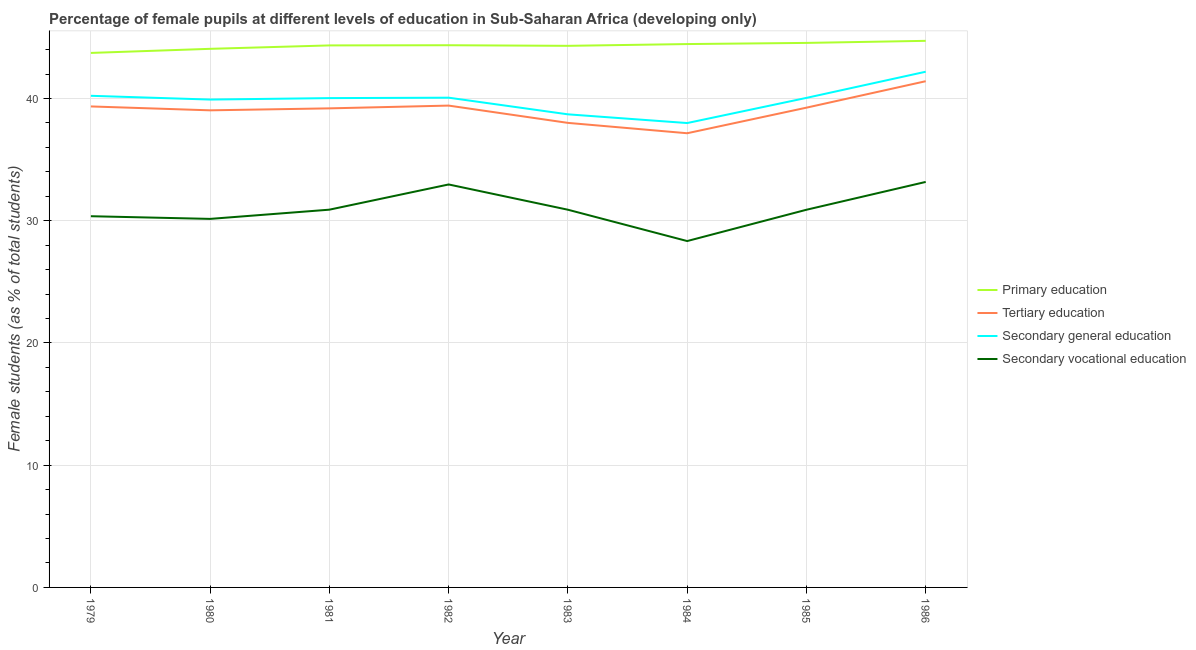How many different coloured lines are there?
Your answer should be compact. 4. Is the number of lines equal to the number of legend labels?
Your response must be concise. Yes. What is the percentage of female students in tertiary education in 1982?
Provide a short and direct response. 39.42. Across all years, what is the maximum percentage of female students in secondary vocational education?
Your answer should be compact. 33.17. Across all years, what is the minimum percentage of female students in secondary vocational education?
Give a very brief answer. 28.34. In which year was the percentage of female students in primary education maximum?
Offer a terse response. 1986. In which year was the percentage of female students in secondary education minimum?
Your answer should be compact. 1984. What is the total percentage of female students in secondary vocational education in the graph?
Ensure brevity in your answer.  247.69. What is the difference between the percentage of female students in secondary vocational education in 1985 and that in 1986?
Your answer should be very brief. -2.28. What is the difference between the percentage of female students in tertiary education in 1982 and the percentage of female students in primary education in 1983?
Offer a terse response. -4.89. What is the average percentage of female students in secondary education per year?
Provide a short and direct response. 39.89. In the year 1982, what is the difference between the percentage of female students in tertiary education and percentage of female students in secondary vocational education?
Your answer should be very brief. 6.45. In how many years, is the percentage of female students in primary education greater than 16 %?
Keep it short and to the point. 8. What is the ratio of the percentage of female students in secondary vocational education in 1981 to that in 1983?
Offer a very short reply. 1. What is the difference between the highest and the second highest percentage of female students in tertiary education?
Offer a very short reply. 1.99. What is the difference between the highest and the lowest percentage of female students in tertiary education?
Your answer should be very brief. 4.26. In how many years, is the percentage of female students in secondary vocational education greater than the average percentage of female students in secondary vocational education taken over all years?
Give a very brief answer. 2. What is the difference between two consecutive major ticks on the Y-axis?
Offer a very short reply. 10. Are the values on the major ticks of Y-axis written in scientific E-notation?
Keep it short and to the point. No. Does the graph contain any zero values?
Provide a succinct answer. No. Where does the legend appear in the graph?
Provide a succinct answer. Center right. What is the title of the graph?
Your answer should be compact. Percentage of female pupils at different levels of education in Sub-Saharan Africa (developing only). What is the label or title of the Y-axis?
Provide a succinct answer. Female students (as % of total students). What is the Female students (as % of total students) of Primary education in 1979?
Ensure brevity in your answer.  43.73. What is the Female students (as % of total students) in Tertiary education in 1979?
Make the answer very short. 39.35. What is the Female students (as % of total students) of Secondary general education in 1979?
Your answer should be very brief. 40.22. What is the Female students (as % of total students) in Secondary vocational education in 1979?
Your response must be concise. 30.37. What is the Female students (as % of total students) in Primary education in 1980?
Give a very brief answer. 44.06. What is the Female students (as % of total students) of Tertiary education in 1980?
Provide a short and direct response. 39.03. What is the Female students (as % of total students) of Secondary general education in 1980?
Your answer should be compact. 39.91. What is the Female students (as % of total students) of Secondary vocational education in 1980?
Offer a terse response. 30.15. What is the Female students (as % of total students) of Primary education in 1981?
Your answer should be very brief. 44.34. What is the Female students (as % of total students) in Tertiary education in 1981?
Provide a short and direct response. 39.19. What is the Female students (as % of total students) of Secondary general education in 1981?
Provide a succinct answer. 40.03. What is the Female students (as % of total students) of Secondary vocational education in 1981?
Your answer should be compact. 30.9. What is the Female students (as % of total students) of Primary education in 1982?
Offer a very short reply. 44.36. What is the Female students (as % of total students) of Tertiary education in 1982?
Ensure brevity in your answer.  39.42. What is the Female students (as % of total students) in Secondary general education in 1982?
Give a very brief answer. 40.06. What is the Female students (as % of total students) in Secondary vocational education in 1982?
Offer a very short reply. 32.97. What is the Female students (as % of total students) of Primary education in 1983?
Your response must be concise. 44.31. What is the Female students (as % of total students) of Tertiary education in 1983?
Offer a terse response. 38. What is the Female students (as % of total students) of Secondary general education in 1983?
Ensure brevity in your answer.  38.7. What is the Female students (as % of total students) of Secondary vocational education in 1983?
Your response must be concise. 30.9. What is the Female students (as % of total students) of Primary education in 1984?
Provide a short and direct response. 44.45. What is the Female students (as % of total students) in Tertiary education in 1984?
Your answer should be very brief. 37.16. What is the Female students (as % of total students) in Secondary general education in 1984?
Offer a terse response. 37.99. What is the Female students (as % of total students) of Secondary vocational education in 1984?
Your answer should be very brief. 28.34. What is the Female students (as % of total students) in Primary education in 1985?
Provide a succinct answer. 44.54. What is the Female students (as % of total students) in Tertiary education in 1985?
Give a very brief answer. 39.25. What is the Female students (as % of total students) of Secondary general education in 1985?
Offer a very short reply. 40.05. What is the Female students (as % of total students) in Secondary vocational education in 1985?
Provide a short and direct response. 30.9. What is the Female students (as % of total students) in Primary education in 1986?
Offer a terse response. 44.71. What is the Female students (as % of total students) of Tertiary education in 1986?
Provide a short and direct response. 41.41. What is the Female students (as % of total students) in Secondary general education in 1986?
Ensure brevity in your answer.  42.19. What is the Female students (as % of total students) of Secondary vocational education in 1986?
Provide a succinct answer. 33.17. Across all years, what is the maximum Female students (as % of total students) of Primary education?
Your answer should be very brief. 44.71. Across all years, what is the maximum Female students (as % of total students) in Tertiary education?
Ensure brevity in your answer.  41.41. Across all years, what is the maximum Female students (as % of total students) in Secondary general education?
Provide a short and direct response. 42.19. Across all years, what is the maximum Female students (as % of total students) of Secondary vocational education?
Offer a very short reply. 33.17. Across all years, what is the minimum Female students (as % of total students) of Primary education?
Keep it short and to the point. 43.73. Across all years, what is the minimum Female students (as % of total students) in Tertiary education?
Your answer should be compact. 37.16. Across all years, what is the minimum Female students (as % of total students) in Secondary general education?
Keep it short and to the point. 37.99. Across all years, what is the minimum Female students (as % of total students) in Secondary vocational education?
Make the answer very short. 28.34. What is the total Female students (as % of total students) of Primary education in the graph?
Make the answer very short. 354.5. What is the total Female students (as % of total students) of Tertiary education in the graph?
Ensure brevity in your answer.  312.8. What is the total Female students (as % of total students) in Secondary general education in the graph?
Make the answer very short. 319.15. What is the total Female students (as % of total students) of Secondary vocational education in the graph?
Make the answer very short. 247.69. What is the difference between the Female students (as % of total students) in Primary education in 1979 and that in 1980?
Your answer should be compact. -0.34. What is the difference between the Female students (as % of total students) of Tertiary education in 1979 and that in 1980?
Ensure brevity in your answer.  0.32. What is the difference between the Female students (as % of total students) of Secondary general education in 1979 and that in 1980?
Your response must be concise. 0.31. What is the difference between the Female students (as % of total students) in Secondary vocational education in 1979 and that in 1980?
Your response must be concise. 0.22. What is the difference between the Female students (as % of total students) of Primary education in 1979 and that in 1981?
Your answer should be very brief. -0.61. What is the difference between the Female students (as % of total students) of Tertiary education in 1979 and that in 1981?
Offer a terse response. 0.16. What is the difference between the Female students (as % of total students) of Secondary general education in 1979 and that in 1981?
Offer a terse response. 0.19. What is the difference between the Female students (as % of total students) in Secondary vocational education in 1979 and that in 1981?
Provide a short and direct response. -0.54. What is the difference between the Female students (as % of total students) of Primary education in 1979 and that in 1982?
Your answer should be compact. -0.63. What is the difference between the Female students (as % of total students) in Tertiary education in 1979 and that in 1982?
Your answer should be very brief. -0.07. What is the difference between the Female students (as % of total students) of Secondary general education in 1979 and that in 1982?
Provide a succinct answer. 0.15. What is the difference between the Female students (as % of total students) in Secondary vocational education in 1979 and that in 1982?
Make the answer very short. -2.6. What is the difference between the Female students (as % of total students) of Primary education in 1979 and that in 1983?
Provide a succinct answer. -0.58. What is the difference between the Female students (as % of total students) in Tertiary education in 1979 and that in 1983?
Make the answer very short. 1.34. What is the difference between the Female students (as % of total students) in Secondary general education in 1979 and that in 1983?
Your answer should be very brief. 1.52. What is the difference between the Female students (as % of total students) of Secondary vocational education in 1979 and that in 1983?
Your answer should be very brief. -0.53. What is the difference between the Female students (as % of total students) in Primary education in 1979 and that in 1984?
Offer a very short reply. -0.73. What is the difference between the Female students (as % of total students) of Tertiary education in 1979 and that in 1984?
Your answer should be compact. 2.19. What is the difference between the Female students (as % of total students) in Secondary general education in 1979 and that in 1984?
Keep it short and to the point. 2.23. What is the difference between the Female students (as % of total students) of Secondary vocational education in 1979 and that in 1984?
Provide a succinct answer. 2.03. What is the difference between the Female students (as % of total students) of Primary education in 1979 and that in 1985?
Your response must be concise. -0.82. What is the difference between the Female students (as % of total students) of Tertiary education in 1979 and that in 1985?
Offer a terse response. 0.1. What is the difference between the Female students (as % of total students) of Secondary general education in 1979 and that in 1985?
Your answer should be very brief. 0.17. What is the difference between the Female students (as % of total students) of Secondary vocational education in 1979 and that in 1985?
Provide a succinct answer. -0.53. What is the difference between the Female students (as % of total students) of Primary education in 1979 and that in 1986?
Your response must be concise. -0.99. What is the difference between the Female students (as % of total students) in Tertiary education in 1979 and that in 1986?
Offer a very short reply. -2.06. What is the difference between the Female students (as % of total students) of Secondary general education in 1979 and that in 1986?
Offer a very short reply. -1.97. What is the difference between the Female students (as % of total students) of Secondary vocational education in 1979 and that in 1986?
Give a very brief answer. -2.8. What is the difference between the Female students (as % of total students) of Primary education in 1980 and that in 1981?
Your answer should be very brief. -0.28. What is the difference between the Female students (as % of total students) of Tertiary education in 1980 and that in 1981?
Your response must be concise. -0.16. What is the difference between the Female students (as % of total students) in Secondary general education in 1980 and that in 1981?
Make the answer very short. -0.12. What is the difference between the Female students (as % of total students) of Secondary vocational education in 1980 and that in 1981?
Your response must be concise. -0.75. What is the difference between the Female students (as % of total students) in Primary education in 1980 and that in 1982?
Provide a succinct answer. -0.29. What is the difference between the Female students (as % of total students) in Tertiary education in 1980 and that in 1982?
Keep it short and to the point. -0.39. What is the difference between the Female students (as % of total students) of Secondary general education in 1980 and that in 1982?
Your answer should be very brief. -0.15. What is the difference between the Female students (as % of total students) of Secondary vocational education in 1980 and that in 1982?
Keep it short and to the point. -2.82. What is the difference between the Female students (as % of total students) in Primary education in 1980 and that in 1983?
Provide a succinct answer. -0.24. What is the difference between the Female students (as % of total students) of Tertiary education in 1980 and that in 1983?
Your answer should be compact. 1.03. What is the difference between the Female students (as % of total students) in Secondary general education in 1980 and that in 1983?
Provide a succinct answer. 1.21. What is the difference between the Female students (as % of total students) in Secondary vocational education in 1980 and that in 1983?
Your response must be concise. -0.75. What is the difference between the Female students (as % of total students) in Primary education in 1980 and that in 1984?
Provide a succinct answer. -0.39. What is the difference between the Female students (as % of total students) in Tertiary education in 1980 and that in 1984?
Provide a succinct answer. 1.87. What is the difference between the Female students (as % of total students) of Secondary general education in 1980 and that in 1984?
Keep it short and to the point. 1.92. What is the difference between the Female students (as % of total students) of Secondary vocational education in 1980 and that in 1984?
Provide a succinct answer. 1.81. What is the difference between the Female students (as % of total students) in Primary education in 1980 and that in 1985?
Offer a very short reply. -0.48. What is the difference between the Female students (as % of total students) of Tertiary education in 1980 and that in 1985?
Provide a short and direct response. -0.22. What is the difference between the Female students (as % of total students) in Secondary general education in 1980 and that in 1985?
Ensure brevity in your answer.  -0.14. What is the difference between the Female students (as % of total students) in Secondary vocational education in 1980 and that in 1985?
Keep it short and to the point. -0.75. What is the difference between the Female students (as % of total students) of Primary education in 1980 and that in 1986?
Ensure brevity in your answer.  -0.65. What is the difference between the Female students (as % of total students) in Tertiary education in 1980 and that in 1986?
Make the answer very short. -2.38. What is the difference between the Female students (as % of total students) of Secondary general education in 1980 and that in 1986?
Provide a short and direct response. -2.28. What is the difference between the Female students (as % of total students) in Secondary vocational education in 1980 and that in 1986?
Your answer should be very brief. -3.02. What is the difference between the Female students (as % of total students) in Primary education in 1981 and that in 1982?
Provide a succinct answer. -0.01. What is the difference between the Female students (as % of total students) in Tertiary education in 1981 and that in 1982?
Provide a succinct answer. -0.23. What is the difference between the Female students (as % of total students) in Secondary general education in 1981 and that in 1982?
Provide a succinct answer. -0.04. What is the difference between the Female students (as % of total students) in Secondary vocational education in 1981 and that in 1982?
Give a very brief answer. -2.06. What is the difference between the Female students (as % of total students) of Primary education in 1981 and that in 1983?
Offer a very short reply. 0.03. What is the difference between the Female students (as % of total students) of Tertiary education in 1981 and that in 1983?
Make the answer very short. 1.19. What is the difference between the Female students (as % of total students) in Secondary general education in 1981 and that in 1983?
Provide a short and direct response. 1.33. What is the difference between the Female students (as % of total students) in Secondary vocational education in 1981 and that in 1983?
Provide a succinct answer. 0. What is the difference between the Female students (as % of total students) in Primary education in 1981 and that in 1984?
Provide a short and direct response. -0.11. What is the difference between the Female students (as % of total students) in Tertiary education in 1981 and that in 1984?
Provide a short and direct response. 2.04. What is the difference between the Female students (as % of total students) of Secondary general education in 1981 and that in 1984?
Make the answer very short. 2.04. What is the difference between the Female students (as % of total students) in Secondary vocational education in 1981 and that in 1984?
Ensure brevity in your answer.  2.57. What is the difference between the Female students (as % of total students) in Primary education in 1981 and that in 1985?
Offer a terse response. -0.2. What is the difference between the Female students (as % of total students) of Tertiary education in 1981 and that in 1985?
Your answer should be very brief. -0.06. What is the difference between the Female students (as % of total students) in Secondary general education in 1981 and that in 1985?
Offer a terse response. -0.02. What is the difference between the Female students (as % of total students) of Secondary vocational education in 1981 and that in 1985?
Your response must be concise. 0.01. What is the difference between the Female students (as % of total students) of Primary education in 1981 and that in 1986?
Offer a terse response. -0.37. What is the difference between the Female students (as % of total students) of Tertiary education in 1981 and that in 1986?
Give a very brief answer. -2.22. What is the difference between the Female students (as % of total students) in Secondary general education in 1981 and that in 1986?
Give a very brief answer. -2.16. What is the difference between the Female students (as % of total students) in Secondary vocational education in 1981 and that in 1986?
Ensure brevity in your answer.  -2.27. What is the difference between the Female students (as % of total students) in Primary education in 1982 and that in 1983?
Ensure brevity in your answer.  0.05. What is the difference between the Female students (as % of total students) in Tertiary education in 1982 and that in 1983?
Keep it short and to the point. 1.41. What is the difference between the Female students (as % of total students) of Secondary general education in 1982 and that in 1983?
Your answer should be very brief. 1.36. What is the difference between the Female students (as % of total students) of Secondary vocational education in 1982 and that in 1983?
Your response must be concise. 2.07. What is the difference between the Female students (as % of total students) of Primary education in 1982 and that in 1984?
Your answer should be compact. -0.1. What is the difference between the Female students (as % of total students) of Tertiary education in 1982 and that in 1984?
Provide a succinct answer. 2.26. What is the difference between the Female students (as % of total students) in Secondary general education in 1982 and that in 1984?
Keep it short and to the point. 2.07. What is the difference between the Female students (as % of total students) in Secondary vocational education in 1982 and that in 1984?
Your answer should be very brief. 4.63. What is the difference between the Female students (as % of total students) in Primary education in 1982 and that in 1985?
Offer a very short reply. -0.19. What is the difference between the Female students (as % of total students) in Tertiary education in 1982 and that in 1985?
Offer a terse response. 0.17. What is the difference between the Female students (as % of total students) of Secondary general education in 1982 and that in 1985?
Your answer should be very brief. 0.02. What is the difference between the Female students (as % of total students) of Secondary vocational education in 1982 and that in 1985?
Your answer should be very brief. 2.07. What is the difference between the Female students (as % of total students) of Primary education in 1982 and that in 1986?
Offer a very short reply. -0.36. What is the difference between the Female students (as % of total students) of Tertiary education in 1982 and that in 1986?
Give a very brief answer. -1.99. What is the difference between the Female students (as % of total students) of Secondary general education in 1982 and that in 1986?
Make the answer very short. -2.12. What is the difference between the Female students (as % of total students) of Secondary vocational education in 1982 and that in 1986?
Keep it short and to the point. -0.21. What is the difference between the Female students (as % of total students) in Primary education in 1983 and that in 1984?
Your answer should be compact. -0.14. What is the difference between the Female students (as % of total students) of Tertiary education in 1983 and that in 1984?
Keep it short and to the point. 0.85. What is the difference between the Female students (as % of total students) in Secondary general education in 1983 and that in 1984?
Give a very brief answer. 0.71. What is the difference between the Female students (as % of total students) of Secondary vocational education in 1983 and that in 1984?
Give a very brief answer. 2.56. What is the difference between the Female students (as % of total students) of Primary education in 1983 and that in 1985?
Ensure brevity in your answer.  -0.24. What is the difference between the Female students (as % of total students) in Tertiary education in 1983 and that in 1985?
Offer a very short reply. -1.25. What is the difference between the Female students (as % of total students) of Secondary general education in 1983 and that in 1985?
Your response must be concise. -1.35. What is the difference between the Female students (as % of total students) in Secondary vocational education in 1983 and that in 1985?
Offer a very short reply. 0. What is the difference between the Female students (as % of total students) in Primary education in 1983 and that in 1986?
Provide a succinct answer. -0.41. What is the difference between the Female students (as % of total students) of Tertiary education in 1983 and that in 1986?
Offer a very short reply. -3.41. What is the difference between the Female students (as % of total students) in Secondary general education in 1983 and that in 1986?
Provide a short and direct response. -3.49. What is the difference between the Female students (as % of total students) in Secondary vocational education in 1983 and that in 1986?
Your answer should be compact. -2.27. What is the difference between the Female students (as % of total students) in Primary education in 1984 and that in 1985?
Make the answer very short. -0.09. What is the difference between the Female students (as % of total students) of Tertiary education in 1984 and that in 1985?
Make the answer very short. -2.09. What is the difference between the Female students (as % of total students) of Secondary general education in 1984 and that in 1985?
Ensure brevity in your answer.  -2.06. What is the difference between the Female students (as % of total students) in Secondary vocational education in 1984 and that in 1985?
Provide a short and direct response. -2.56. What is the difference between the Female students (as % of total students) in Primary education in 1984 and that in 1986?
Your answer should be compact. -0.26. What is the difference between the Female students (as % of total students) of Tertiary education in 1984 and that in 1986?
Your response must be concise. -4.26. What is the difference between the Female students (as % of total students) in Secondary general education in 1984 and that in 1986?
Make the answer very short. -4.2. What is the difference between the Female students (as % of total students) in Secondary vocational education in 1984 and that in 1986?
Offer a terse response. -4.84. What is the difference between the Female students (as % of total students) in Primary education in 1985 and that in 1986?
Make the answer very short. -0.17. What is the difference between the Female students (as % of total students) in Tertiary education in 1985 and that in 1986?
Your answer should be compact. -2.16. What is the difference between the Female students (as % of total students) of Secondary general education in 1985 and that in 1986?
Your answer should be very brief. -2.14. What is the difference between the Female students (as % of total students) in Secondary vocational education in 1985 and that in 1986?
Provide a succinct answer. -2.28. What is the difference between the Female students (as % of total students) in Primary education in 1979 and the Female students (as % of total students) in Tertiary education in 1980?
Give a very brief answer. 4.7. What is the difference between the Female students (as % of total students) in Primary education in 1979 and the Female students (as % of total students) in Secondary general education in 1980?
Your response must be concise. 3.81. What is the difference between the Female students (as % of total students) in Primary education in 1979 and the Female students (as % of total students) in Secondary vocational education in 1980?
Keep it short and to the point. 13.58. What is the difference between the Female students (as % of total students) of Tertiary education in 1979 and the Female students (as % of total students) of Secondary general education in 1980?
Provide a succinct answer. -0.56. What is the difference between the Female students (as % of total students) in Tertiary education in 1979 and the Female students (as % of total students) in Secondary vocational education in 1980?
Keep it short and to the point. 9.2. What is the difference between the Female students (as % of total students) of Secondary general education in 1979 and the Female students (as % of total students) of Secondary vocational education in 1980?
Keep it short and to the point. 10.07. What is the difference between the Female students (as % of total students) of Primary education in 1979 and the Female students (as % of total students) of Tertiary education in 1981?
Your response must be concise. 4.53. What is the difference between the Female students (as % of total students) of Primary education in 1979 and the Female students (as % of total students) of Secondary general education in 1981?
Give a very brief answer. 3.7. What is the difference between the Female students (as % of total students) of Primary education in 1979 and the Female students (as % of total students) of Secondary vocational education in 1981?
Keep it short and to the point. 12.82. What is the difference between the Female students (as % of total students) in Tertiary education in 1979 and the Female students (as % of total students) in Secondary general education in 1981?
Your answer should be very brief. -0.68. What is the difference between the Female students (as % of total students) of Tertiary education in 1979 and the Female students (as % of total students) of Secondary vocational education in 1981?
Ensure brevity in your answer.  8.44. What is the difference between the Female students (as % of total students) in Secondary general education in 1979 and the Female students (as % of total students) in Secondary vocational education in 1981?
Offer a very short reply. 9.32. What is the difference between the Female students (as % of total students) of Primary education in 1979 and the Female students (as % of total students) of Tertiary education in 1982?
Make the answer very short. 4.31. What is the difference between the Female students (as % of total students) of Primary education in 1979 and the Female students (as % of total students) of Secondary general education in 1982?
Your response must be concise. 3.66. What is the difference between the Female students (as % of total students) in Primary education in 1979 and the Female students (as % of total students) in Secondary vocational education in 1982?
Provide a succinct answer. 10.76. What is the difference between the Female students (as % of total students) of Tertiary education in 1979 and the Female students (as % of total students) of Secondary general education in 1982?
Provide a short and direct response. -0.72. What is the difference between the Female students (as % of total students) of Tertiary education in 1979 and the Female students (as % of total students) of Secondary vocational education in 1982?
Provide a short and direct response. 6.38. What is the difference between the Female students (as % of total students) of Secondary general education in 1979 and the Female students (as % of total students) of Secondary vocational education in 1982?
Provide a succinct answer. 7.25. What is the difference between the Female students (as % of total students) in Primary education in 1979 and the Female students (as % of total students) in Tertiary education in 1983?
Provide a short and direct response. 5.72. What is the difference between the Female students (as % of total students) in Primary education in 1979 and the Female students (as % of total students) in Secondary general education in 1983?
Your answer should be very brief. 5.02. What is the difference between the Female students (as % of total students) in Primary education in 1979 and the Female students (as % of total students) in Secondary vocational education in 1983?
Give a very brief answer. 12.83. What is the difference between the Female students (as % of total students) in Tertiary education in 1979 and the Female students (as % of total students) in Secondary general education in 1983?
Your answer should be very brief. 0.65. What is the difference between the Female students (as % of total students) of Tertiary education in 1979 and the Female students (as % of total students) of Secondary vocational education in 1983?
Keep it short and to the point. 8.45. What is the difference between the Female students (as % of total students) of Secondary general education in 1979 and the Female students (as % of total students) of Secondary vocational education in 1983?
Your response must be concise. 9.32. What is the difference between the Female students (as % of total students) in Primary education in 1979 and the Female students (as % of total students) in Tertiary education in 1984?
Ensure brevity in your answer.  6.57. What is the difference between the Female students (as % of total students) of Primary education in 1979 and the Female students (as % of total students) of Secondary general education in 1984?
Ensure brevity in your answer.  5.74. What is the difference between the Female students (as % of total students) in Primary education in 1979 and the Female students (as % of total students) in Secondary vocational education in 1984?
Your response must be concise. 15.39. What is the difference between the Female students (as % of total students) of Tertiary education in 1979 and the Female students (as % of total students) of Secondary general education in 1984?
Offer a terse response. 1.36. What is the difference between the Female students (as % of total students) in Tertiary education in 1979 and the Female students (as % of total students) in Secondary vocational education in 1984?
Your answer should be very brief. 11.01. What is the difference between the Female students (as % of total students) in Secondary general education in 1979 and the Female students (as % of total students) in Secondary vocational education in 1984?
Make the answer very short. 11.88. What is the difference between the Female students (as % of total students) in Primary education in 1979 and the Female students (as % of total students) in Tertiary education in 1985?
Give a very brief answer. 4.48. What is the difference between the Female students (as % of total students) of Primary education in 1979 and the Female students (as % of total students) of Secondary general education in 1985?
Your answer should be very brief. 3.68. What is the difference between the Female students (as % of total students) in Primary education in 1979 and the Female students (as % of total students) in Secondary vocational education in 1985?
Provide a succinct answer. 12.83. What is the difference between the Female students (as % of total students) of Tertiary education in 1979 and the Female students (as % of total students) of Secondary general education in 1985?
Keep it short and to the point. -0.7. What is the difference between the Female students (as % of total students) in Tertiary education in 1979 and the Female students (as % of total students) in Secondary vocational education in 1985?
Give a very brief answer. 8.45. What is the difference between the Female students (as % of total students) in Secondary general education in 1979 and the Female students (as % of total students) in Secondary vocational education in 1985?
Provide a succinct answer. 9.32. What is the difference between the Female students (as % of total students) in Primary education in 1979 and the Female students (as % of total students) in Tertiary education in 1986?
Make the answer very short. 2.31. What is the difference between the Female students (as % of total students) of Primary education in 1979 and the Female students (as % of total students) of Secondary general education in 1986?
Ensure brevity in your answer.  1.54. What is the difference between the Female students (as % of total students) in Primary education in 1979 and the Female students (as % of total students) in Secondary vocational education in 1986?
Your answer should be very brief. 10.55. What is the difference between the Female students (as % of total students) of Tertiary education in 1979 and the Female students (as % of total students) of Secondary general education in 1986?
Make the answer very short. -2.84. What is the difference between the Female students (as % of total students) in Tertiary education in 1979 and the Female students (as % of total students) in Secondary vocational education in 1986?
Your answer should be very brief. 6.18. What is the difference between the Female students (as % of total students) in Secondary general education in 1979 and the Female students (as % of total students) in Secondary vocational education in 1986?
Offer a terse response. 7.05. What is the difference between the Female students (as % of total students) of Primary education in 1980 and the Female students (as % of total students) of Tertiary education in 1981?
Give a very brief answer. 4.87. What is the difference between the Female students (as % of total students) in Primary education in 1980 and the Female students (as % of total students) in Secondary general education in 1981?
Provide a succinct answer. 4.03. What is the difference between the Female students (as % of total students) in Primary education in 1980 and the Female students (as % of total students) in Secondary vocational education in 1981?
Your response must be concise. 13.16. What is the difference between the Female students (as % of total students) of Tertiary education in 1980 and the Female students (as % of total students) of Secondary general education in 1981?
Make the answer very short. -1. What is the difference between the Female students (as % of total students) in Tertiary education in 1980 and the Female students (as % of total students) in Secondary vocational education in 1981?
Give a very brief answer. 8.13. What is the difference between the Female students (as % of total students) of Secondary general education in 1980 and the Female students (as % of total students) of Secondary vocational education in 1981?
Give a very brief answer. 9.01. What is the difference between the Female students (as % of total students) of Primary education in 1980 and the Female students (as % of total students) of Tertiary education in 1982?
Offer a very short reply. 4.64. What is the difference between the Female students (as % of total students) of Primary education in 1980 and the Female students (as % of total students) of Secondary general education in 1982?
Ensure brevity in your answer.  4. What is the difference between the Female students (as % of total students) in Primary education in 1980 and the Female students (as % of total students) in Secondary vocational education in 1982?
Ensure brevity in your answer.  11.1. What is the difference between the Female students (as % of total students) of Tertiary education in 1980 and the Female students (as % of total students) of Secondary general education in 1982?
Your answer should be very brief. -1.03. What is the difference between the Female students (as % of total students) in Tertiary education in 1980 and the Female students (as % of total students) in Secondary vocational education in 1982?
Your response must be concise. 6.06. What is the difference between the Female students (as % of total students) in Secondary general education in 1980 and the Female students (as % of total students) in Secondary vocational education in 1982?
Your answer should be very brief. 6.95. What is the difference between the Female students (as % of total students) of Primary education in 1980 and the Female students (as % of total students) of Tertiary education in 1983?
Your response must be concise. 6.06. What is the difference between the Female students (as % of total students) in Primary education in 1980 and the Female students (as % of total students) in Secondary general education in 1983?
Your answer should be very brief. 5.36. What is the difference between the Female students (as % of total students) in Primary education in 1980 and the Female students (as % of total students) in Secondary vocational education in 1983?
Your response must be concise. 13.16. What is the difference between the Female students (as % of total students) in Tertiary education in 1980 and the Female students (as % of total students) in Secondary general education in 1983?
Your response must be concise. 0.33. What is the difference between the Female students (as % of total students) of Tertiary education in 1980 and the Female students (as % of total students) of Secondary vocational education in 1983?
Make the answer very short. 8.13. What is the difference between the Female students (as % of total students) of Secondary general education in 1980 and the Female students (as % of total students) of Secondary vocational education in 1983?
Give a very brief answer. 9.01. What is the difference between the Female students (as % of total students) in Primary education in 1980 and the Female students (as % of total students) in Tertiary education in 1984?
Your answer should be very brief. 6.91. What is the difference between the Female students (as % of total students) in Primary education in 1980 and the Female students (as % of total students) in Secondary general education in 1984?
Offer a very short reply. 6.07. What is the difference between the Female students (as % of total students) in Primary education in 1980 and the Female students (as % of total students) in Secondary vocational education in 1984?
Give a very brief answer. 15.73. What is the difference between the Female students (as % of total students) in Tertiary education in 1980 and the Female students (as % of total students) in Secondary general education in 1984?
Provide a succinct answer. 1.04. What is the difference between the Female students (as % of total students) in Tertiary education in 1980 and the Female students (as % of total students) in Secondary vocational education in 1984?
Provide a short and direct response. 10.69. What is the difference between the Female students (as % of total students) of Secondary general education in 1980 and the Female students (as % of total students) of Secondary vocational education in 1984?
Your answer should be compact. 11.58. What is the difference between the Female students (as % of total students) in Primary education in 1980 and the Female students (as % of total students) in Tertiary education in 1985?
Your answer should be very brief. 4.81. What is the difference between the Female students (as % of total students) in Primary education in 1980 and the Female students (as % of total students) in Secondary general education in 1985?
Your response must be concise. 4.01. What is the difference between the Female students (as % of total students) of Primary education in 1980 and the Female students (as % of total students) of Secondary vocational education in 1985?
Your answer should be compact. 13.17. What is the difference between the Female students (as % of total students) of Tertiary education in 1980 and the Female students (as % of total students) of Secondary general education in 1985?
Your answer should be compact. -1.02. What is the difference between the Female students (as % of total students) of Tertiary education in 1980 and the Female students (as % of total students) of Secondary vocational education in 1985?
Offer a very short reply. 8.13. What is the difference between the Female students (as % of total students) in Secondary general education in 1980 and the Female students (as % of total students) in Secondary vocational education in 1985?
Make the answer very short. 9.01. What is the difference between the Female students (as % of total students) of Primary education in 1980 and the Female students (as % of total students) of Tertiary education in 1986?
Make the answer very short. 2.65. What is the difference between the Female students (as % of total students) of Primary education in 1980 and the Female students (as % of total students) of Secondary general education in 1986?
Ensure brevity in your answer.  1.87. What is the difference between the Female students (as % of total students) in Primary education in 1980 and the Female students (as % of total students) in Secondary vocational education in 1986?
Give a very brief answer. 10.89. What is the difference between the Female students (as % of total students) of Tertiary education in 1980 and the Female students (as % of total students) of Secondary general education in 1986?
Make the answer very short. -3.16. What is the difference between the Female students (as % of total students) of Tertiary education in 1980 and the Female students (as % of total students) of Secondary vocational education in 1986?
Keep it short and to the point. 5.86. What is the difference between the Female students (as % of total students) of Secondary general education in 1980 and the Female students (as % of total students) of Secondary vocational education in 1986?
Your response must be concise. 6.74. What is the difference between the Female students (as % of total students) in Primary education in 1981 and the Female students (as % of total students) in Tertiary education in 1982?
Provide a succinct answer. 4.92. What is the difference between the Female students (as % of total students) of Primary education in 1981 and the Female students (as % of total students) of Secondary general education in 1982?
Your answer should be compact. 4.28. What is the difference between the Female students (as % of total students) of Primary education in 1981 and the Female students (as % of total students) of Secondary vocational education in 1982?
Offer a very short reply. 11.37. What is the difference between the Female students (as % of total students) in Tertiary education in 1981 and the Female students (as % of total students) in Secondary general education in 1982?
Your response must be concise. -0.87. What is the difference between the Female students (as % of total students) in Tertiary education in 1981 and the Female students (as % of total students) in Secondary vocational education in 1982?
Give a very brief answer. 6.23. What is the difference between the Female students (as % of total students) of Secondary general education in 1981 and the Female students (as % of total students) of Secondary vocational education in 1982?
Keep it short and to the point. 7.06. What is the difference between the Female students (as % of total students) in Primary education in 1981 and the Female students (as % of total students) in Tertiary education in 1983?
Offer a very short reply. 6.34. What is the difference between the Female students (as % of total students) in Primary education in 1981 and the Female students (as % of total students) in Secondary general education in 1983?
Offer a terse response. 5.64. What is the difference between the Female students (as % of total students) of Primary education in 1981 and the Female students (as % of total students) of Secondary vocational education in 1983?
Your answer should be compact. 13.44. What is the difference between the Female students (as % of total students) in Tertiary education in 1981 and the Female students (as % of total students) in Secondary general education in 1983?
Provide a short and direct response. 0.49. What is the difference between the Female students (as % of total students) of Tertiary education in 1981 and the Female students (as % of total students) of Secondary vocational education in 1983?
Make the answer very short. 8.29. What is the difference between the Female students (as % of total students) in Secondary general education in 1981 and the Female students (as % of total students) in Secondary vocational education in 1983?
Provide a short and direct response. 9.13. What is the difference between the Female students (as % of total students) in Primary education in 1981 and the Female students (as % of total students) in Tertiary education in 1984?
Keep it short and to the point. 7.18. What is the difference between the Female students (as % of total students) of Primary education in 1981 and the Female students (as % of total students) of Secondary general education in 1984?
Your response must be concise. 6.35. What is the difference between the Female students (as % of total students) of Primary education in 1981 and the Female students (as % of total students) of Secondary vocational education in 1984?
Your answer should be very brief. 16. What is the difference between the Female students (as % of total students) of Tertiary education in 1981 and the Female students (as % of total students) of Secondary general education in 1984?
Provide a succinct answer. 1.2. What is the difference between the Female students (as % of total students) in Tertiary education in 1981 and the Female students (as % of total students) in Secondary vocational education in 1984?
Offer a very short reply. 10.86. What is the difference between the Female students (as % of total students) of Secondary general education in 1981 and the Female students (as % of total students) of Secondary vocational education in 1984?
Your answer should be very brief. 11.69. What is the difference between the Female students (as % of total students) of Primary education in 1981 and the Female students (as % of total students) of Tertiary education in 1985?
Ensure brevity in your answer.  5.09. What is the difference between the Female students (as % of total students) in Primary education in 1981 and the Female students (as % of total students) in Secondary general education in 1985?
Provide a succinct answer. 4.29. What is the difference between the Female students (as % of total students) of Primary education in 1981 and the Female students (as % of total students) of Secondary vocational education in 1985?
Provide a short and direct response. 13.44. What is the difference between the Female students (as % of total students) in Tertiary education in 1981 and the Female students (as % of total students) in Secondary general education in 1985?
Offer a very short reply. -0.86. What is the difference between the Female students (as % of total students) of Tertiary education in 1981 and the Female students (as % of total students) of Secondary vocational education in 1985?
Your answer should be compact. 8.3. What is the difference between the Female students (as % of total students) in Secondary general education in 1981 and the Female students (as % of total students) in Secondary vocational education in 1985?
Make the answer very short. 9.13. What is the difference between the Female students (as % of total students) of Primary education in 1981 and the Female students (as % of total students) of Tertiary education in 1986?
Give a very brief answer. 2.93. What is the difference between the Female students (as % of total students) in Primary education in 1981 and the Female students (as % of total students) in Secondary general education in 1986?
Offer a terse response. 2.15. What is the difference between the Female students (as % of total students) of Primary education in 1981 and the Female students (as % of total students) of Secondary vocational education in 1986?
Make the answer very short. 11.17. What is the difference between the Female students (as % of total students) in Tertiary education in 1981 and the Female students (as % of total students) in Secondary general education in 1986?
Make the answer very short. -3. What is the difference between the Female students (as % of total students) of Tertiary education in 1981 and the Female students (as % of total students) of Secondary vocational education in 1986?
Make the answer very short. 6.02. What is the difference between the Female students (as % of total students) in Secondary general education in 1981 and the Female students (as % of total students) in Secondary vocational education in 1986?
Provide a succinct answer. 6.86. What is the difference between the Female students (as % of total students) of Primary education in 1982 and the Female students (as % of total students) of Tertiary education in 1983?
Offer a terse response. 6.35. What is the difference between the Female students (as % of total students) in Primary education in 1982 and the Female students (as % of total students) in Secondary general education in 1983?
Make the answer very short. 5.65. What is the difference between the Female students (as % of total students) in Primary education in 1982 and the Female students (as % of total students) in Secondary vocational education in 1983?
Offer a terse response. 13.46. What is the difference between the Female students (as % of total students) of Tertiary education in 1982 and the Female students (as % of total students) of Secondary general education in 1983?
Keep it short and to the point. 0.71. What is the difference between the Female students (as % of total students) of Tertiary education in 1982 and the Female students (as % of total students) of Secondary vocational education in 1983?
Provide a succinct answer. 8.52. What is the difference between the Female students (as % of total students) in Secondary general education in 1982 and the Female students (as % of total students) in Secondary vocational education in 1983?
Your answer should be compact. 9.17. What is the difference between the Female students (as % of total students) of Primary education in 1982 and the Female students (as % of total students) of Tertiary education in 1984?
Make the answer very short. 7.2. What is the difference between the Female students (as % of total students) in Primary education in 1982 and the Female students (as % of total students) in Secondary general education in 1984?
Ensure brevity in your answer.  6.37. What is the difference between the Female students (as % of total students) in Primary education in 1982 and the Female students (as % of total students) in Secondary vocational education in 1984?
Ensure brevity in your answer.  16.02. What is the difference between the Female students (as % of total students) of Tertiary education in 1982 and the Female students (as % of total students) of Secondary general education in 1984?
Ensure brevity in your answer.  1.43. What is the difference between the Female students (as % of total students) of Tertiary education in 1982 and the Female students (as % of total students) of Secondary vocational education in 1984?
Ensure brevity in your answer.  11.08. What is the difference between the Female students (as % of total students) of Secondary general education in 1982 and the Female students (as % of total students) of Secondary vocational education in 1984?
Provide a succinct answer. 11.73. What is the difference between the Female students (as % of total students) in Primary education in 1982 and the Female students (as % of total students) in Tertiary education in 1985?
Offer a terse response. 5.11. What is the difference between the Female students (as % of total students) of Primary education in 1982 and the Female students (as % of total students) of Secondary general education in 1985?
Offer a very short reply. 4.31. What is the difference between the Female students (as % of total students) of Primary education in 1982 and the Female students (as % of total students) of Secondary vocational education in 1985?
Provide a succinct answer. 13.46. What is the difference between the Female students (as % of total students) of Tertiary education in 1982 and the Female students (as % of total students) of Secondary general education in 1985?
Provide a succinct answer. -0.63. What is the difference between the Female students (as % of total students) in Tertiary education in 1982 and the Female students (as % of total students) in Secondary vocational education in 1985?
Make the answer very short. 8.52. What is the difference between the Female students (as % of total students) of Secondary general education in 1982 and the Female students (as % of total students) of Secondary vocational education in 1985?
Your answer should be very brief. 9.17. What is the difference between the Female students (as % of total students) in Primary education in 1982 and the Female students (as % of total students) in Tertiary education in 1986?
Offer a very short reply. 2.94. What is the difference between the Female students (as % of total students) of Primary education in 1982 and the Female students (as % of total students) of Secondary general education in 1986?
Make the answer very short. 2.17. What is the difference between the Female students (as % of total students) of Primary education in 1982 and the Female students (as % of total students) of Secondary vocational education in 1986?
Provide a succinct answer. 11.18. What is the difference between the Female students (as % of total students) of Tertiary education in 1982 and the Female students (as % of total students) of Secondary general education in 1986?
Your response must be concise. -2.77. What is the difference between the Female students (as % of total students) of Tertiary education in 1982 and the Female students (as % of total students) of Secondary vocational education in 1986?
Offer a terse response. 6.24. What is the difference between the Female students (as % of total students) of Secondary general education in 1982 and the Female students (as % of total students) of Secondary vocational education in 1986?
Your answer should be compact. 6.89. What is the difference between the Female students (as % of total students) in Primary education in 1983 and the Female students (as % of total students) in Tertiary education in 1984?
Your answer should be very brief. 7.15. What is the difference between the Female students (as % of total students) in Primary education in 1983 and the Female students (as % of total students) in Secondary general education in 1984?
Provide a short and direct response. 6.32. What is the difference between the Female students (as % of total students) in Primary education in 1983 and the Female students (as % of total students) in Secondary vocational education in 1984?
Your answer should be very brief. 15.97. What is the difference between the Female students (as % of total students) of Tertiary education in 1983 and the Female students (as % of total students) of Secondary general education in 1984?
Your response must be concise. 0.01. What is the difference between the Female students (as % of total students) of Tertiary education in 1983 and the Female students (as % of total students) of Secondary vocational education in 1984?
Your answer should be very brief. 9.67. What is the difference between the Female students (as % of total students) in Secondary general education in 1983 and the Female students (as % of total students) in Secondary vocational education in 1984?
Provide a short and direct response. 10.37. What is the difference between the Female students (as % of total students) in Primary education in 1983 and the Female students (as % of total students) in Tertiary education in 1985?
Offer a very short reply. 5.06. What is the difference between the Female students (as % of total students) of Primary education in 1983 and the Female students (as % of total students) of Secondary general education in 1985?
Make the answer very short. 4.26. What is the difference between the Female students (as % of total students) of Primary education in 1983 and the Female students (as % of total students) of Secondary vocational education in 1985?
Make the answer very short. 13.41. What is the difference between the Female students (as % of total students) of Tertiary education in 1983 and the Female students (as % of total students) of Secondary general education in 1985?
Make the answer very short. -2.04. What is the difference between the Female students (as % of total students) of Tertiary education in 1983 and the Female students (as % of total students) of Secondary vocational education in 1985?
Ensure brevity in your answer.  7.11. What is the difference between the Female students (as % of total students) of Secondary general education in 1983 and the Female students (as % of total students) of Secondary vocational education in 1985?
Make the answer very short. 7.81. What is the difference between the Female students (as % of total students) in Primary education in 1983 and the Female students (as % of total students) in Tertiary education in 1986?
Offer a very short reply. 2.9. What is the difference between the Female students (as % of total students) in Primary education in 1983 and the Female students (as % of total students) in Secondary general education in 1986?
Offer a terse response. 2.12. What is the difference between the Female students (as % of total students) in Primary education in 1983 and the Female students (as % of total students) in Secondary vocational education in 1986?
Offer a terse response. 11.13. What is the difference between the Female students (as % of total students) of Tertiary education in 1983 and the Female students (as % of total students) of Secondary general education in 1986?
Ensure brevity in your answer.  -4.18. What is the difference between the Female students (as % of total students) in Tertiary education in 1983 and the Female students (as % of total students) in Secondary vocational education in 1986?
Your answer should be compact. 4.83. What is the difference between the Female students (as % of total students) of Secondary general education in 1983 and the Female students (as % of total students) of Secondary vocational education in 1986?
Offer a terse response. 5.53. What is the difference between the Female students (as % of total students) in Primary education in 1984 and the Female students (as % of total students) in Tertiary education in 1985?
Your answer should be compact. 5.2. What is the difference between the Female students (as % of total students) of Primary education in 1984 and the Female students (as % of total students) of Secondary general education in 1985?
Keep it short and to the point. 4.4. What is the difference between the Female students (as % of total students) in Primary education in 1984 and the Female students (as % of total students) in Secondary vocational education in 1985?
Provide a succinct answer. 13.55. What is the difference between the Female students (as % of total students) of Tertiary education in 1984 and the Female students (as % of total students) of Secondary general education in 1985?
Provide a short and direct response. -2.89. What is the difference between the Female students (as % of total students) of Tertiary education in 1984 and the Female students (as % of total students) of Secondary vocational education in 1985?
Provide a short and direct response. 6.26. What is the difference between the Female students (as % of total students) of Secondary general education in 1984 and the Female students (as % of total students) of Secondary vocational education in 1985?
Keep it short and to the point. 7.09. What is the difference between the Female students (as % of total students) of Primary education in 1984 and the Female students (as % of total students) of Tertiary education in 1986?
Make the answer very short. 3.04. What is the difference between the Female students (as % of total students) of Primary education in 1984 and the Female students (as % of total students) of Secondary general education in 1986?
Give a very brief answer. 2.26. What is the difference between the Female students (as % of total students) in Primary education in 1984 and the Female students (as % of total students) in Secondary vocational education in 1986?
Your answer should be very brief. 11.28. What is the difference between the Female students (as % of total students) of Tertiary education in 1984 and the Female students (as % of total students) of Secondary general education in 1986?
Your answer should be very brief. -5.03. What is the difference between the Female students (as % of total students) in Tertiary education in 1984 and the Female students (as % of total students) in Secondary vocational education in 1986?
Give a very brief answer. 3.98. What is the difference between the Female students (as % of total students) of Secondary general education in 1984 and the Female students (as % of total students) of Secondary vocational education in 1986?
Keep it short and to the point. 4.82. What is the difference between the Female students (as % of total students) in Primary education in 1985 and the Female students (as % of total students) in Tertiary education in 1986?
Provide a short and direct response. 3.13. What is the difference between the Female students (as % of total students) in Primary education in 1985 and the Female students (as % of total students) in Secondary general education in 1986?
Offer a very short reply. 2.36. What is the difference between the Female students (as % of total students) in Primary education in 1985 and the Female students (as % of total students) in Secondary vocational education in 1986?
Ensure brevity in your answer.  11.37. What is the difference between the Female students (as % of total students) of Tertiary education in 1985 and the Female students (as % of total students) of Secondary general education in 1986?
Keep it short and to the point. -2.94. What is the difference between the Female students (as % of total students) in Tertiary education in 1985 and the Female students (as % of total students) in Secondary vocational education in 1986?
Provide a succinct answer. 6.08. What is the difference between the Female students (as % of total students) of Secondary general education in 1985 and the Female students (as % of total students) of Secondary vocational education in 1986?
Your response must be concise. 6.88. What is the average Female students (as % of total students) in Primary education per year?
Give a very brief answer. 44.31. What is the average Female students (as % of total students) of Tertiary education per year?
Make the answer very short. 39.1. What is the average Female students (as % of total students) of Secondary general education per year?
Ensure brevity in your answer.  39.89. What is the average Female students (as % of total students) of Secondary vocational education per year?
Ensure brevity in your answer.  30.96. In the year 1979, what is the difference between the Female students (as % of total students) of Primary education and Female students (as % of total students) of Tertiary education?
Your answer should be compact. 4.38. In the year 1979, what is the difference between the Female students (as % of total students) in Primary education and Female students (as % of total students) in Secondary general education?
Offer a terse response. 3.51. In the year 1979, what is the difference between the Female students (as % of total students) in Primary education and Female students (as % of total students) in Secondary vocational education?
Provide a succinct answer. 13.36. In the year 1979, what is the difference between the Female students (as % of total students) in Tertiary education and Female students (as % of total students) in Secondary general education?
Provide a short and direct response. -0.87. In the year 1979, what is the difference between the Female students (as % of total students) of Tertiary education and Female students (as % of total students) of Secondary vocational education?
Your response must be concise. 8.98. In the year 1979, what is the difference between the Female students (as % of total students) in Secondary general education and Female students (as % of total students) in Secondary vocational education?
Ensure brevity in your answer.  9.85. In the year 1980, what is the difference between the Female students (as % of total students) of Primary education and Female students (as % of total students) of Tertiary education?
Provide a succinct answer. 5.03. In the year 1980, what is the difference between the Female students (as % of total students) of Primary education and Female students (as % of total students) of Secondary general education?
Your answer should be very brief. 4.15. In the year 1980, what is the difference between the Female students (as % of total students) of Primary education and Female students (as % of total students) of Secondary vocational education?
Offer a very short reply. 13.91. In the year 1980, what is the difference between the Female students (as % of total students) of Tertiary education and Female students (as % of total students) of Secondary general education?
Provide a succinct answer. -0.88. In the year 1980, what is the difference between the Female students (as % of total students) in Tertiary education and Female students (as % of total students) in Secondary vocational education?
Your response must be concise. 8.88. In the year 1980, what is the difference between the Female students (as % of total students) in Secondary general education and Female students (as % of total students) in Secondary vocational education?
Ensure brevity in your answer.  9.76. In the year 1981, what is the difference between the Female students (as % of total students) in Primary education and Female students (as % of total students) in Tertiary education?
Provide a succinct answer. 5.15. In the year 1981, what is the difference between the Female students (as % of total students) of Primary education and Female students (as % of total students) of Secondary general education?
Keep it short and to the point. 4.31. In the year 1981, what is the difference between the Female students (as % of total students) in Primary education and Female students (as % of total students) in Secondary vocational education?
Make the answer very short. 13.44. In the year 1981, what is the difference between the Female students (as % of total students) in Tertiary education and Female students (as % of total students) in Secondary general education?
Your response must be concise. -0.84. In the year 1981, what is the difference between the Female students (as % of total students) in Tertiary education and Female students (as % of total students) in Secondary vocational education?
Offer a terse response. 8.29. In the year 1981, what is the difference between the Female students (as % of total students) in Secondary general education and Female students (as % of total students) in Secondary vocational education?
Provide a succinct answer. 9.13. In the year 1982, what is the difference between the Female students (as % of total students) in Primary education and Female students (as % of total students) in Tertiary education?
Provide a succinct answer. 4.94. In the year 1982, what is the difference between the Female students (as % of total students) in Primary education and Female students (as % of total students) in Secondary general education?
Offer a very short reply. 4.29. In the year 1982, what is the difference between the Female students (as % of total students) in Primary education and Female students (as % of total students) in Secondary vocational education?
Ensure brevity in your answer.  11.39. In the year 1982, what is the difference between the Female students (as % of total students) in Tertiary education and Female students (as % of total students) in Secondary general education?
Keep it short and to the point. -0.65. In the year 1982, what is the difference between the Female students (as % of total students) of Tertiary education and Female students (as % of total students) of Secondary vocational education?
Your answer should be compact. 6.45. In the year 1982, what is the difference between the Female students (as % of total students) in Secondary general education and Female students (as % of total students) in Secondary vocational education?
Make the answer very short. 7.1. In the year 1983, what is the difference between the Female students (as % of total students) in Primary education and Female students (as % of total students) in Tertiary education?
Ensure brevity in your answer.  6.3. In the year 1983, what is the difference between the Female students (as % of total students) of Primary education and Female students (as % of total students) of Secondary general education?
Provide a succinct answer. 5.6. In the year 1983, what is the difference between the Female students (as % of total students) of Primary education and Female students (as % of total students) of Secondary vocational education?
Your answer should be very brief. 13.41. In the year 1983, what is the difference between the Female students (as % of total students) of Tertiary education and Female students (as % of total students) of Secondary general education?
Keep it short and to the point. -0.7. In the year 1983, what is the difference between the Female students (as % of total students) of Tertiary education and Female students (as % of total students) of Secondary vocational education?
Offer a very short reply. 7.1. In the year 1983, what is the difference between the Female students (as % of total students) of Secondary general education and Female students (as % of total students) of Secondary vocational education?
Offer a very short reply. 7.8. In the year 1984, what is the difference between the Female students (as % of total students) of Primary education and Female students (as % of total students) of Tertiary education?
Keep it short and to the point. 7.3. In the year 1984, what is the difference between the Female students (as % of total students) in Primary education and Female students (as % of total students) in Secondary general education?
Your answer should be very brief. 6.46. In the year 1984, what is the difference between the Female students (as % of total students) in Primary education and Female students (as % of total students) in Secondary vocational education?
Your answer should be compact. 16.12. In the year 1984, what is the difference between the Female students (as % of total students) of Tertiary education and Female students (as % of total students) of Secondary general education?
Provide a short and direct response. -0.83. In the year 1984, what is the difference between the Female students (as % of total students) of Tertiary education and Female students (as % of total students) of Secondary vocational education?
Keep it short and to the point. 8.82. In the year 1984, what is the difference between the Female students (as % of total students) of Secondary general education and Female students (as % of total students) of Secondary vocational education?
Give a very brief answer. 9.65. In the year 1985, what is the difference between the Female students (as % of total students) in Primary education and Female students (as % of total students) in Tertiary education?
Keep it short and to the point. 5.3. In the year 1985, what is the difference between the Female students (as % of total students) in Primary education and Female students (as % of total students) in Secondary general education?
Your response must be concise. 4.5. In the year 1985, what is the difference between the Female students (as % of total students) of Primary education and Female students (as % of total students) of Secondary vocational education?
Your answer should be compact. 13.65. In the year 1985, what is the difference between the Female students (as % of total students) of Tertiary education and Female students (as % of total students) of Secondary general education?
Your answer should be very brief. -0.8. In the year 1985, what is the difference between the Female students (as % of total students) of Tertiary education and Female students (as % of total students) of Secondary vocational education?
Offer a very short reply. 8.35. In the year 1985, what is the difference between the Female students (as % of total students) in Secondary general education and Female students (as % of total students) in Secondary vocational education?
Your answer should be very brief. 9.15. In the year 1986, what is the difference between the Female students (as % of total students) of Primary education and Female students (as % of total students) of Tertiary education?
Your answer should be compact. 3.3. In the year 1986, what is the difference between the Female students (as % of total students) of Primary education and Female students (as % of total students) of Secondary general education?
Offer a terse response. 2.53. In the year 1986, what is the difference between the Female students (as % of total students) of Primary education and Female students (as % of total students) of Secondary vocational education?
Keep it short and to the point. 11.54. In the year 1986, what is the difference between the Female students (as % of total students) of Tertiary education and Female students (as % of total students) of Secondary general education?
Provide a succinct answer. -0.78. In the year 1986, what is the difference between the Female students (as % of total students) of Tertiary education and Female students (as % of total students) of Secondary vocational education?
Your response must be concise. 8.24. In the year 1986, what is the difference between the Female students (as % of total students) of Secondary general education and Female students (as % of total students) of Secondary vocational education?
Provide a succinct answer. 9.02. What is the ratio of the Female students (as % of total students) in Tertiary education in 1979 to that in 1980?
Offer a terse response. 1.01. What is the ratio of the Female students (as % of total students) of Secondary general education in 1979 to that in 1980?
Your response must be concise. 1.01. What is the ratio of the Female students (as % of total students) of Secondary vocational education in 1979 to that in 1980?
Make the answer very short. 1.01. What is the ratio of the Female students (as % of total students) of Primary education in 1979 to that in 1981?
Offer a terse response. 0.99. What is the ratio of the Female students (as % of total students) of Secondary general education in 1979 to that in 1981?
Provide a succinct answer. 1. What is the ratio of the Female students (as % of total students) in Secondary vocational education in 1979 to that in 1981?
Your response must be concise. 0.98. What is the ratio of the Female students (as % of total students) in Primary education in 1979 to that in 1982?
Keep it short and to the point. 0.99. What is the ratio of the Female students (as % of total students) of Secondary general education in 1979 to that in 1982?
Your answer should be very brief. 1. What is the ratio of the Female students (as % of total students) of Secondary vocational education in 1979 to that in 1982?
Offer a terse response. 0.92. What is the ratio of the Female students (as % of total students) in Primary education in 1979 to that in 1983?
Provide a short and direct response. 0.99. What is the ratio of the Female students (as % of total students) of Tertiary education in 1979 to that in 1983?
Make the answer very short. 1.04. What is the ratio of the Female students (as % of total students) of Secondary general education in 1979 to that in 1983?
Your answer should be compact. 1.04. What is the ratio of the Female students (as % of total students) in Secondary vocational education in 1979 to that in 1983?
Offer a terse response. 0.98. What is the ratio of the Female students (as % of total students) of Primary education in 1979 to that in 1984?
Provide a short and direct response. 0.98. What is the ratio of the Female students (as % of total students) of Tertiary education in 1979 to that in 1984?
Provide a succinct answer. 1.06. What is the ratio of the Female students (as % of total students) in Secondary general education in 1979 to that in 1984?
Your answer should be very brief. 1.06. What is the ratio of the Female students (as % of total students) in Secondary vocational education in 1979 to that in 1984?
Offer a very short reply. 1.07. What is the ratio of the Female students (as % of total students) in Primary education in 1979 to that in 1985?
Keep it short and to the point. 0.98. What is the ratio of the Female students (as % of total students) in Secondary general education in 1979 to that in 1985?
Offer a very short reply. 1. What is the ratio of the Female students (as % of total students) of Secondary vocational education in 1979 to that in 1985?
Ensure brevity in your answer.  0.98. What is the ratio of the Female students (as % of total students) in Primary education in 1979 to that in 1986?
Provide a short and direct response. 0.98. What is the ratio of the Female students (as % of total students) in Tertiary education in 1979 to that in 1986?
Give a very brief answer. 0.95. What is the ratio of the Female students (as % of total students) of Secondary general education in 1979 to that in 1986?
Your answer should be very brief. 0.95. What is the ratio of the Female students (as % of total students) in Secondary vocational education in 1979 to that in 1986?
Your answer should be compact. 0.92. What is the ratio of the Female students (as % of total students) in Tertiary education in 1980 to that in 1981?
Make the answer very short. 1. What is the ratio of the Female students (as % of total students) in Secondary general education in 1980 to that in 1981?
Provide a succinct answer. 1. What is the ratio of the Female students (as % of total students) in Secondary vocational education in 1980 to that in 1981?
Offer a terse response. 0.98. What is the ratio of the Female students (as % of total students) in Tertiary education in 1980 to that in 1982?
Your answer should be very brief. 0.99. What is the ratio of the Female students (as % of total students) in Secondary general education in 1980 to that in 1982?
Your answer should be very brief. 1. What is the ratio of the Female students (as % of total students) of Secondary vocational education in 1980 to that in 1982?
Make the answer very short. 0.91. What is the ratio of the Female students (as % of total students) of Tertiary education in 1980 to that in 1983?
Offer a very short reply. 1.03. What is the ratio of the Female students (as % of total students) in Secondary general education in 1980 to that in 1983?
Ensure brevity in your answer.  1.03. What is the ratio of the Female students (as % of total students) of Secondary vocational education in 1980 to that in 1983?
Your response must be concise. 0.98. What is the ratio of the Female students (as % of total students) in Primary education in 1980 to that in 1984?
Keep it short and to the point. 0.99. What is the ratio of the Female students (as % of total students) in Tertiary education in 1980 to that in 1984?
Keep it short and to the point. 1.05. What is the ratio of the Female students (as % of total students) of Secondary general education in 1980 to that in 1984?
Your answer should be compact. 1.05. What is the ratio of the Female students (as % of total students) in Secondary vocational education in 1980 to that in 1984?
Your answer should be compact. 1.06. What is the ratio of the Female students (as % of total students) of Primary education in 1980 to that in 1985?
Provide a short and direct response. 0.99. What is the ratio of the Female students (as % of total students) of Tertiary education in 1980 to that in 1985?
Make the answer very short. 0.99. What is the ratio of the Female students (as % of total students) of Secondary vocational education in 1980 to that in 1985?
Keep it short and to the point. 0.98. What is the ratio of the Female students (as % of total students) in Primary education in 1980 to that in 1986?
Make the answer very short. 0.99. What is the ratio of the Female students (as % of total students) of Tertiary education in 1980 to that in 1986?
Make the answer very short. 0.94. What is the ratio of the Female students (as % of total students) of Secondary general education in 1980 to that in 1986?
Offer a terse response. 0.95. What is the ratio of the Female students (as % of total students) in Secondary vocational education in 1980 to that in 1986?
Make the answer very short. 0.91. What is the ratio of the Female students (as % of total students) in Primary education in 1981 to that in 1982?
Offer a terse response. 1. What is the ratio of the Female students (as % of total students) in Secondary vocational education in 1981 to that in 1982?
Provide a succinct answer. 0.94. What is the ratio of the Female students (as % of total students) in Primary education in 1981 to that in 1983?
Your answer should be very brief. 1. What is the ratio of the Female students (as % of total students) of Tertiary education in 1981 to that in 1983?
Your answer should be compact. 1.03. What is the ratio of the Female students (as % of total students) of Secondary general education in 1981 to that in 1983?
Your response must be concise. 1.03. What is the ratio of the Female students (as % of total students) in Secondary vocational education in 1981 to that in 1983?
Provide a short and direct response. 1. What is the ratio of the Female students (as % of total students) of Primary education in 1981 to that in 1984?
Your response must be concise. 1. What is the ratio of the Female students (as % of total students) in Tertiary education in 1981 to that in 1984?
Make the answer very short. 1.05. What is the ratio of the Female students (as % of total students) of Secondary general education in 1981 to that in 1984?
Offer a terse response. 1.05. What is the ratio of the Female students (as % of total students) in Secondary vocational education in 1981 to that in 1984?
Make the answer very short. 1.09. What is the ratio of the Female students (as % of total students) of Secondary general education in 1981 to that in 1985?
Provide a succinct answer. 1. What is the ratio of the Female students (as % of total students) of Secondary vocational education in 1981 to that in 1985?
Provide a succinct answer. 1. What is the ratio of the Female students (as % of total students) in Tertiary education in 1981 to that in 1986?
Give a very brief answer. 0.95. What is the ratio of the Female students (as % of total students) of Secondary general education in 1981 to that in 1986?
Provide a short and direct response. 0.95. What is the ratio of the Female students (as % of total students) in Secondary vocational education in 1981 to that in 1986?
Provide a succinct answer. 0.93. What is the ratio of the Female students (as % of total students) of Tertiary education in 1982 to that in 1983?
Your response must be concise. 1.04. What is the ratio of the Female students (as % of total students) in Secondary general education in 1982 to that in 1983?
Your response must be concise. 1.04. What is the ratio of the Female students (as % of total students) in Secondary vocational education in 1982 to that in 1983?
Make the answer very short. 1.07. What is the ratio of the Female students (as % of total students) in Tertiary education in 1982 to that in 1984?
Your answer should be compact. 1.06. What is the ratio of the Female students (as % of total students) in Secondary general education in 1982 to that in 1984?
Offer a very short reply. 1.05. What is the ratio of the Female students (as % of total students) in Secondary vocational education in 1982 to that in 1984?
Give a very brief answer. 1.16. What is the ratio of the Female students (as % of total students) of Secondary general education in 1982 to that in 1985?
Give a very brief answer. 1. What is the ratio of the Female students (as % of total students) in Secondary vocational education in 1982 to that in 1985?
Your answer should be very brief. 1.07. What is the ratio of the Female students (as % of total students) of Tertiary education in 1982 to that in 1986?
Make the answer very short. 0.95. What is the ratio of the Female students (as % of total students) of Secondary general education in 1982 to that in 1986?
Your response must be concise. 0.95. What is the ratio of the Female students (as % of total students) of Primary education in 1983 to that in 1984?
Keep it short and to the point. 1. What is the ratio of the Female students (as % of total students) of Tertiary education in 1983 to that in 1984?
Keep it short and to the point. 1.02. What is the ratio of the Female students (as % of total students) in Secondary general education in 1983 to that in 1984?
Your answer should be compact. 1.02. What is the ratio of the Female students (as % of total students) of Secondary vocational education in 1983 to that in 1984?
Give a very brief answer. 1.09. What is the ratio of the Female students (as % of total students) of Tertiary education in 1983 to that in 1985?
Provide a succinct answer. 0.97. What is the ratio of the Female students (as % of total students) in Secondary general education in 1983 to that in 1985?
Offer a terse response. 0.97. What is the ratio of the Female students (as % of total students) of Secondary vocational education in 1983 to that in 1985?
Your answer should be very brief. 1. What is the ratio of the Female students (as % of total students) of Primary education in 1983 to that in 1986?
Ensure brevity in your answer.  0.99. What is the ratio of the Female students (as % of total students) of Tertiary education in 1983 to that in 1986?
Provide a succinct answer. 0.92. What is the ratio of the Female students (as % of total students) of Secondary general education in 1983 to that in 1986?
Keep it short and to the point. 0.92. What is the ratio of the Female students (as % of total students) of Secondary vocational education in 1983 to that in 1986?
Your response must be concise. 0.93. What is the ratio of the Female students (as % of total students) in Tertiary education in 1984 to that in 1985?
Ensure brevity in your answer.  0.95. What is the ratio of the Female students (as % of total students) of Secondary general education in 1984 to that in 1985?
Keep it short and to the point. 0.95. What is the ratio of the Female students (as % of total students) in Secondary vocational education in 1984 to that in 1985?
Your answer should be compact. 0.92. What is the ratio of the Female students (as % of total students) in Tertiary education in 1984 to that in 1986?
Your answer should be very brief. 0.9. What is the ratio of the Female students (as % of total students) in Secondary general education in 1984 to that in 1986?
Your answer should be very brief. 0.9. What is the ratio of the Female students (as % of total students) of Secondary vocational education in 1984 to that in 1986?
Your answer should be compact. 0.85. What is the ratio of the Female students (as % of total students) in Primary education in 1985 to that in 1986?
Keep it short and to the point. 1. What is the ratio of the Female students (as % of total students) in Tertiary education in 1985 to that in 1986?
Give a very brief answer. 0.95. What is the ratio of the Female students (as % of total students) of Secondary general education in 1985 to that in 1986?
Offer a terse response. 0.95. What is the ratio of the Female students (as % of total students) of Secondary vocational education in 1985 to that in 1986?
Provide a succinct answer. 0.93. What is the difference between the highest and the second highest Female students (as % of total students) of Primary education?
Your answer should be compact. 0.17. What is the difference between the highest and the second highest Female students (as % of total students) of Tertiary education?
Your answer should be very brief. 1.99. What is the difference between the highest and the second highest Female students (as % of total students) of Secondary general education?
Provide a short and direct response. 1.97. What is the difference between the highest and the second highest Female students (as % of total students) of Secondary vocational education?
Give a very brief answer. 0.21. What is the difference between the highest and the lowest Female students (as % of total students) in Tertiary education?
Provide a short and direct response. 4.26. What is the difference between the highest and the lowest Female students (as % of total students) in Secondary general education?
Provide a short and direct response. 4.2. What is the difference between the highest and the lowest Female students (as % of total students) of Secondary vocational education?
Ensure brevity in your answer.  4.84. 